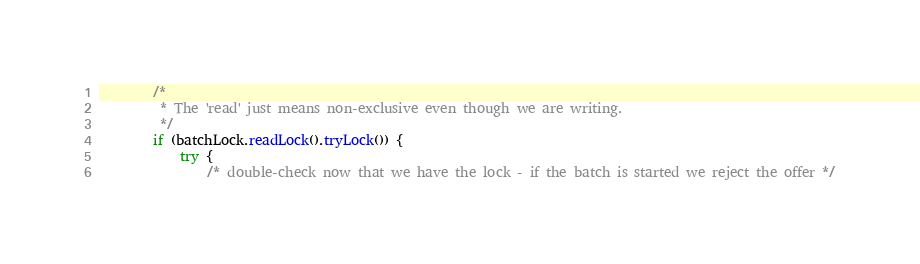<code> <loc_0><loc_0><loc_500><loc_500><_Java_>
        /*
         * The 'read' just means non-exclusive even though we are writing.
         */
        if (batchLock.readLock().tryLock()) {
            try {
                /* double-check now that we have the lock - if the batch is started we reject the offer */</code> 